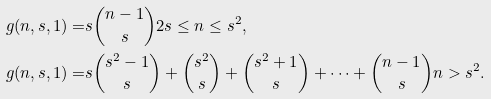Convert formula to latex. <formula><loc_0><loc_0><loc_500><loc_500>g ( n , s , 1 ) = & s { n - 1 \choose s } 2 s \leq n \leq s ^ { 2 } , \\ g ( n , s , 1 ) = & s { s ^ { 2 } - 1 \choose s } + { s ^ { 2 } \choose s } + { s ^ { 2 } + 1 \choose s } + \dots + { n - 1 \choose s } n > s ^ { 2 } .</formula> 